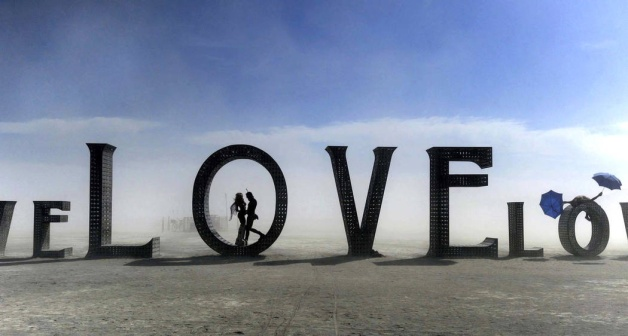Could the umbrella have a meaning beyond its practical use? Certainly, the umbrella often symbolizes protection and shelter. In this setting, it could metaphorically signify personal shielding from the vulnerabilities of love or perhaps a barrier one maintains to avoid emotional engagement. Its isolated use in a seemingly clear setting might also hint at the individual's preparedness for unforeseen challenges. Is there a reason why the word 'LOVE' is constructed from what looks like crates? Using crates to construct the word 'LOVE' could be suggestive of the idea that love is something to be built, often from simple, raw components. Crates, typically used for carrying valuable items, here carry the weight of the message, symbolizing both the fragility and the foundational strength of love. 